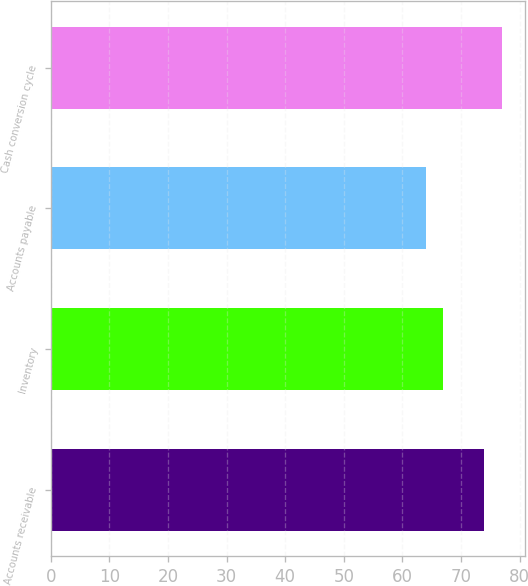Convert chart. <chart><loc_0><loc_0><loc_500><loc_500><bar_chart><fcel>Accounts receivable<fcel>Inventory<fcel>Accounts payable<fcel>Cash conversion cycle<nl><fcel>74<fcel>67<fcel>64<fcel>77<nl></chart> 